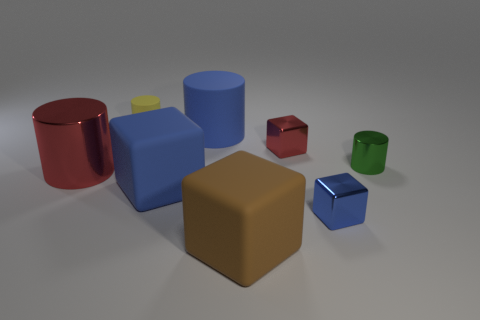Subtract all blue spheres. How many blue cubes are left? 2 Subtract 2 cylinders. How many cylinders are left? 2 Add 2 large red metal things. How many objects exist? 10 Subtract all brown blocks. How many blocks are left? 3 Subtract all small yellow cylinders. How many cylinders are left? 3 Subtract all cyan blocks. Subtract all cyan spheres. How many blocks are left? 4 Add 5 large red metallic things. How many large red metallic things are left? 6 Add 4 tiny yellow objects. How many tiny yellow objects exist? 5 Subtract 1 yellow cylinders. How many objects are left? 7 Subtract all blue rubber things. Subtract all big metallic cylinders. How many objects are left? 5 